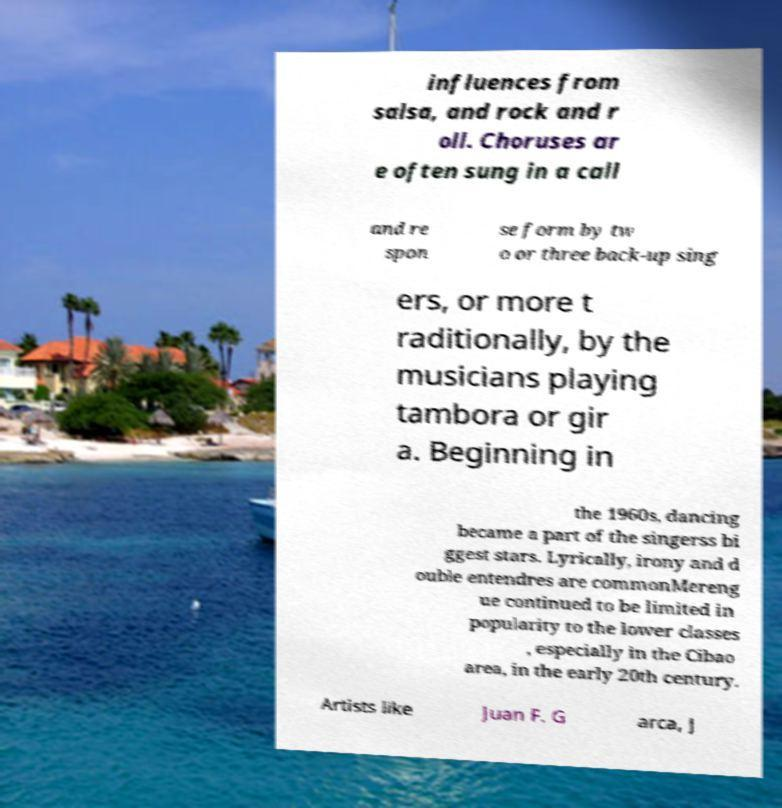Could you extract and type out the text from this image? influences from salsa, and rock and r oll. Choruses ar e often sung in a call and re spon se form by tw o or three back-up sing ers, or more t raditionally, by the musicians playing tambora or gir a. Beginning in the 1960s, dancing became a part of the singerss bi ggest stars. Lyrically, irony and d ouble entendres are commonMereng ue continued to be limited in popularity to the lower classes , especially in the Cibao area, in the early 20th century. Artists like Juan F. G arca, J 